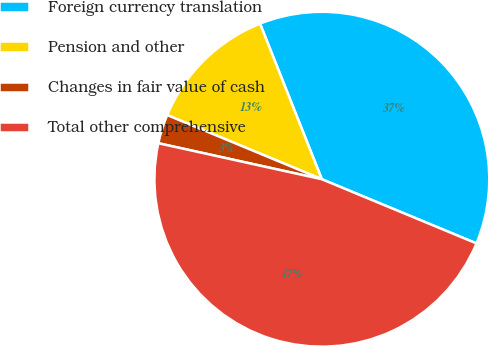Convert chart to OTSL. <chart><loc_0><loc_0><loc_500><loc_500><pie_chart><fcel>Foreign currency translation<fcel>Pension and other<fcel>Changes in fair value of cash<fcel>Total other comprehensive<nl><fcel>37.28%<fcel>12.72%<fcel>2.81%<fcel>47.19%<nl></chart> 